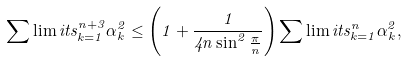<formula> <loc_0><loc_0><loc_500><loc_500>\sum \lim i t s _ { k = 1 } ^ { n + 3 } \alpha _ { k } ^ { 2 } \leq \left ( 1 + \frac { 1 } { 4 n \sin ^ { 2 } \frac { \pi } { n } } \right ) \sum \lim i t s _ { k = 1 } ^ { n } \alpha _ { k } ^ { 2 } ,</formula> 